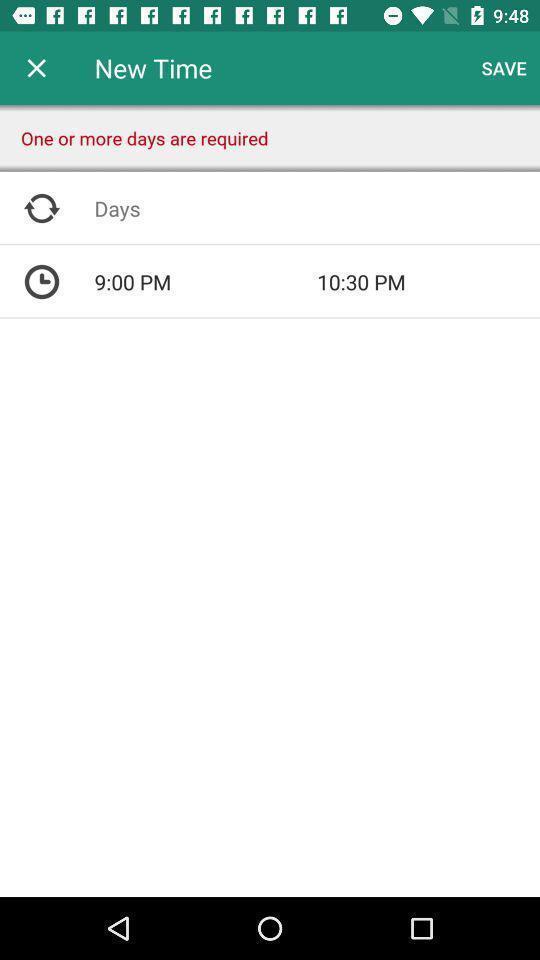Tell me what you see in this picture. Screen displaying time reminders on a study app. 